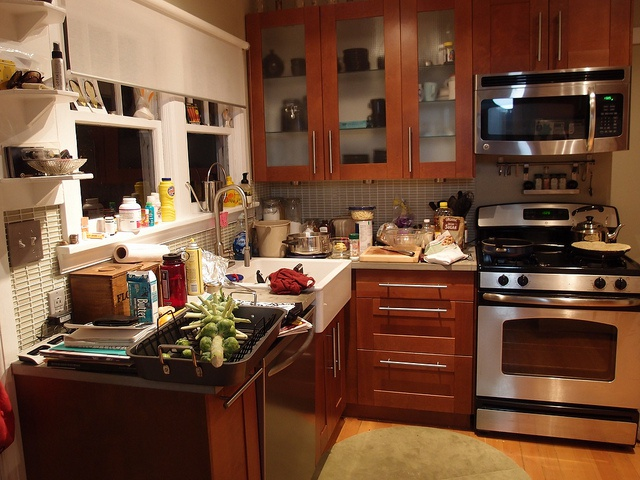Describe the objects in this image and their specific colors. I can see oven in brown, black, gray, and maroon tones, microwave in brown, black, maroon, and gray tones, sink in brown, beige, tan, and gray tones, bottle in brown, gray, maroon, and black tones, and bottle in brown, maroon, and black tones in this image. 